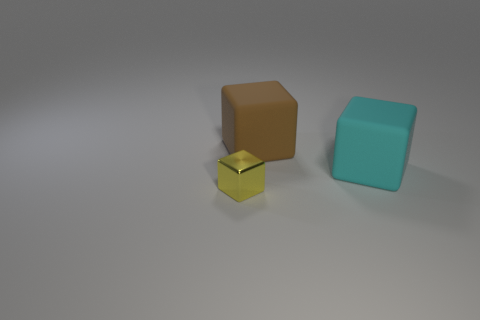Is the yellow metal thing the same size as the brown matte thing?
Give a very brief answer. No. Is there another metal block that has the same size as the yellow metallic block?
Provide a succinct answer. No. What material is the small yellow block left of the large cyan matte thing?
Offer a very short reply. Metal. The large block that is the same material as the big cyan thing is what color?
Offer a terse response. Brown. How many rubber objects are either big brown objects or small brown things?
Your answer should be compact. 1. There is a brown matte thing that is the same size as the cyan rubber cube; what is its shape?
Your answer should be compact. Cube. What number of things are blocks on the right side of the shiny cube or things that are in front of the big cyan rubber thing?
Your response must be concise. 3. What material is the brown block that is the same size as the cyan block?
Give a very brief answer. Rubber. How many other things are the same material as the small yellow block?
Your answer should be very brief. 0. Are there an equal number of tiny blocks right of the cyan object and large things that are behind the tiny yellow metallic block?
Your answer should be compact. No. 